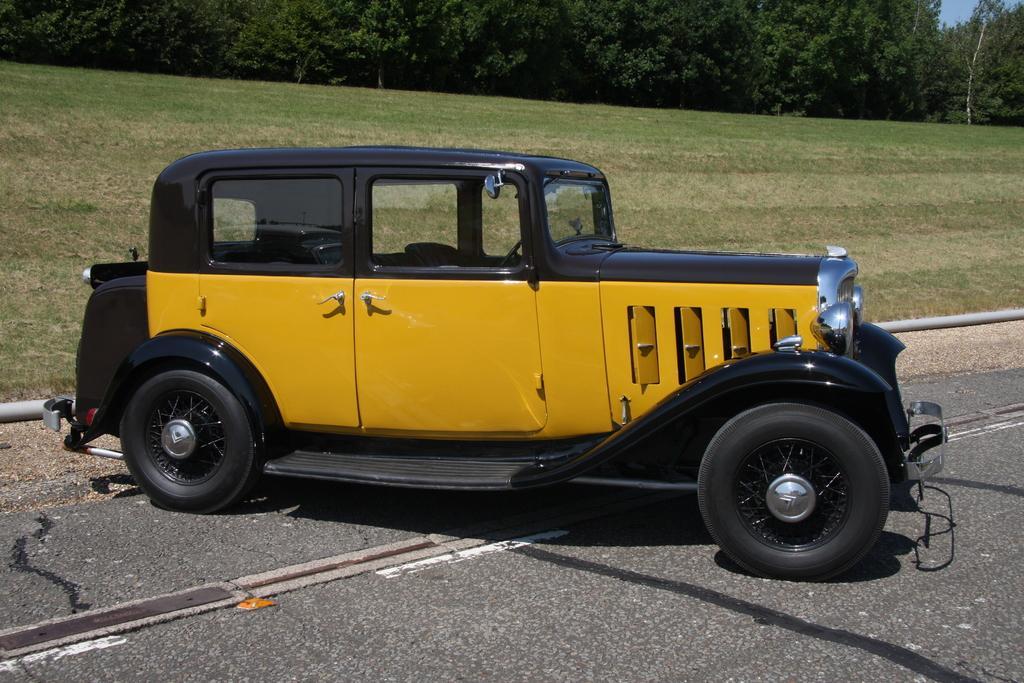Please provide a concise description of this image. In this image we can see many trees. There is a grassy land in the image. There is a sky at the right side of the image. There is a vehicle in the image. There is a pipe in the image. 